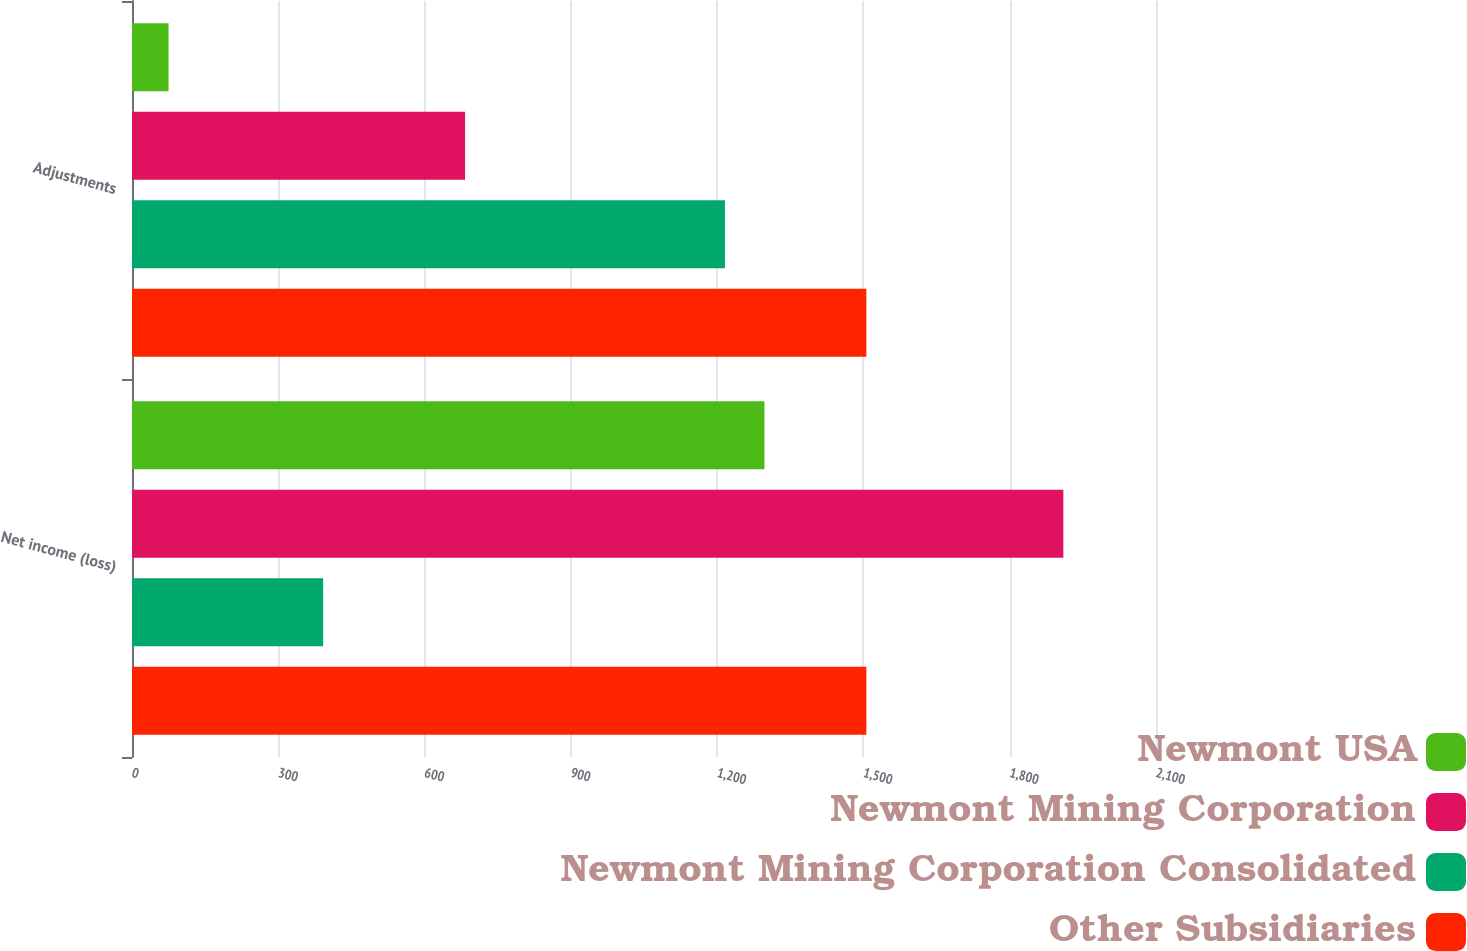Convert chart. <chart><loc_0><loc_0><loc_500><loc_500><stacked_bar_chart><ecel><fcel>Net income (loss)<fcel>Adjustments<nl><fcel>Newmont USA<fcel>1297<fcel>75<nl><fcel>Newmont Mining Corporation<fcel>1910<fcel>683<nl><fcel>Newmont Mining Corporation Consolidated<fcel>392<fcel>1216<nl><fcel>Other Subsidiaries<fcel>1506<fcel>1506<nl></chart> 